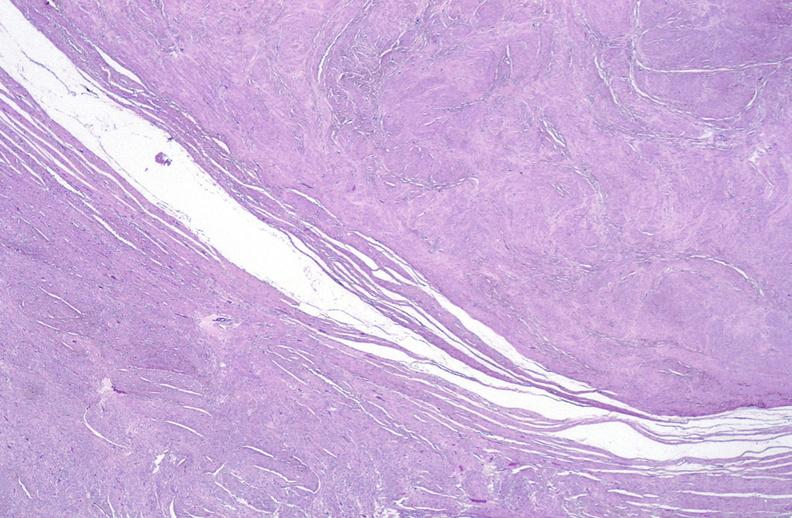what does this image show?
Answer the question using a single word or phrase. Leiomyoma 